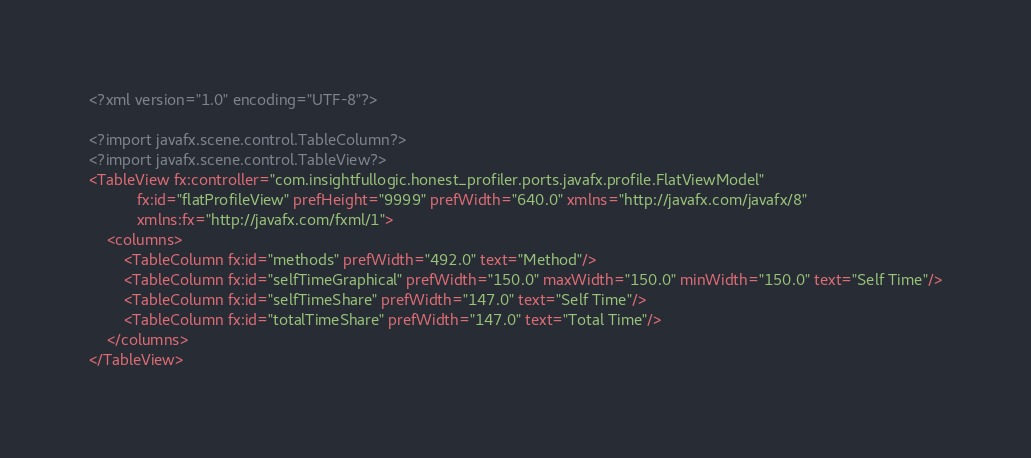Convert code to text. <code><loc_0><loc_0><loc_500><loc_500><_XML_><?xml version="1.0" encoding="UTF-8"?>

<?import javafx.scene.control.TableColumn?>
<?import javafx.scene.control.TableView?>
<TableView fx:controller="com.insightfullogic.honest_profiler.ports.javafx.profile.FlatViewModel"
           fx:id="flatProfileView" prefHeight="9999" prefWidth="640.0" xmlns="http://javafx.com/javafx/8"
           xmlns:fx="http://javafx.com/fxml/1">
    <columns>
        <TableColumn fx:id="methods" prefWidth="492.0" text="Method"/>
        <TableColumn fx:id="selfTimeGraphical" prefWidth="150.0" maxWidth="150.0" minWidth="150.0" text="Self Time"/>
        <TableColumn fx:id="selfTimeShare" prefWidth="147.0" text="Self Time"/>
        <TableColumn fx:id="totalTimeShare" prefWidth="147.0" text="Total Time"/>
    </columns>
</TableView>
</code> 